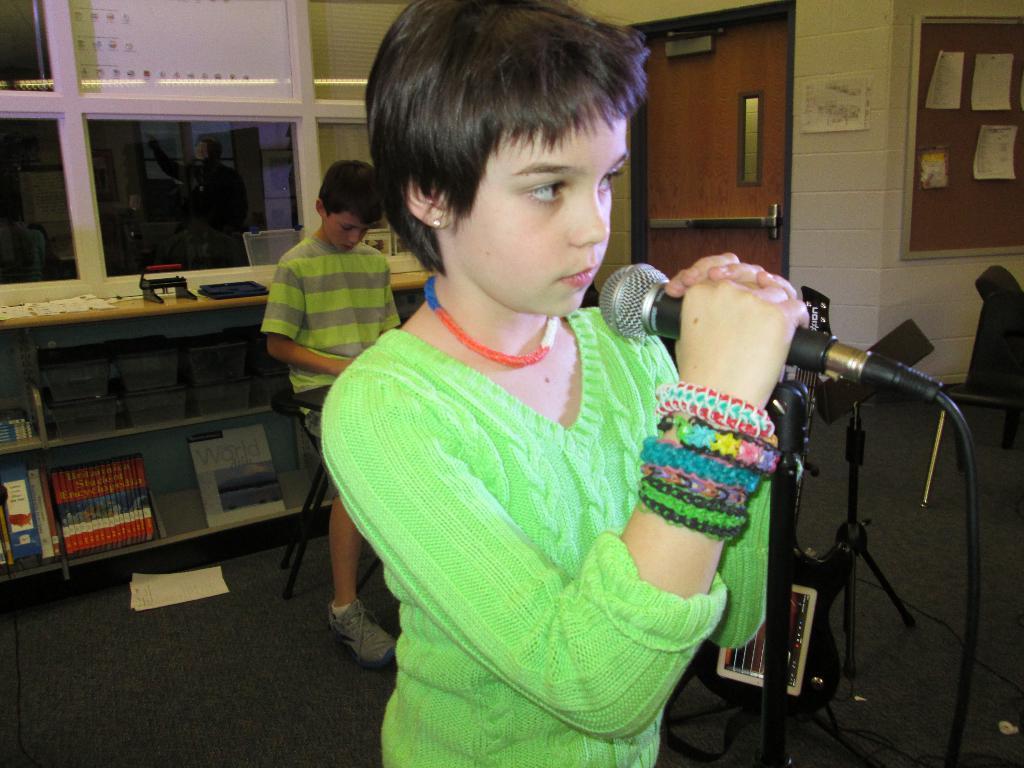How would you summarize this image in a sentence or two? In this picture we can see a person in green dress holding a mic and behind him that is another boy sitting on the stool in front of the table on which there is a there some books and shelf in which some things are placed and behind then there is a notice board and a door. 